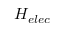Convert formula to latex. <formula><loc_0><loc_0><loc_500><loc_500>H _ { e l e c }</formula> 